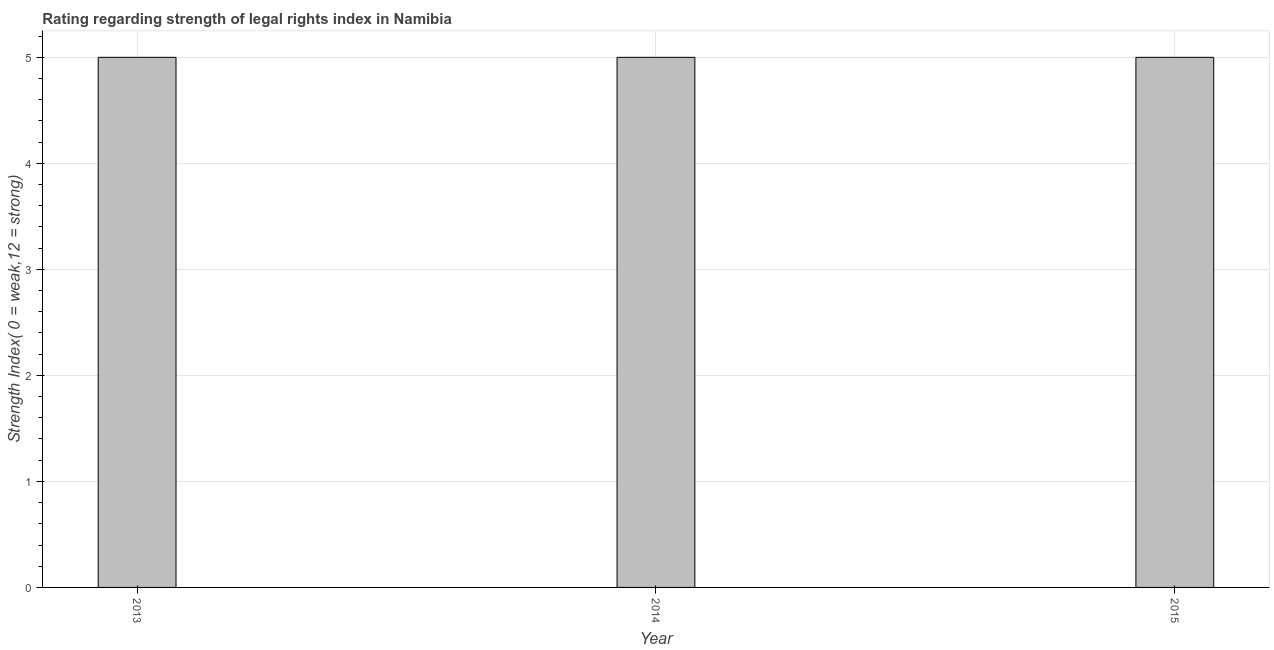Does the graph contain any zero values?
Provide a short and direct response. No. What is the title of the graph?
Offer a terse response. Rating regarding strength of legal rights index in Namibia. What is the label or title of the Y-axis?
Make the answer very short. Strength Index( 0 = weak,12 = strong). What is the strength of legal rights index in 2013?
Provide a short and direct response. 5. What is the average strength of legal rights index per year?
Make the answer very short. 5. What is the ratio of the strength of legal rights index in 2014 to that in 2015?
Offer a very short reply. 1. Is the strength of legal rights index in 2014 less than that in 2015?
Your answer should be compact. No. Is the difference between the strength of legal rights index in 2014 and 2015 greater than the difference between any two years?
Offer a very short reply. Yes. Is the sum of the strength of legal rights index in 2013 and 2014 greater than the maximum strength of legal rights index across all years?
Keep it short and to the point. Yes. In how many years, is the strength of legal rights index greater than the average strength of legal rights index taken over all years?
Ensure brevity in your answer.  0. How many bars are there?
Your response must be concise. 3. Are all the bars in the graph horizontal?
Provide a short and direct response. No. How many years are there in the graph?
Provide a short and direct response. 3. Are the values on the major ticks of Y-axis written in scientific E-notation?
Your response must be concise. No. What is the Strength Index( 0 = weak,12 = strong) of 2013?
Your answer should be very brief. 5. What is the Strength Index( 0 = weak,12 = strong) in 2014?
Your response must be concise. 5. What is the Strength Index( 0 = weak,12 = strong) of 2015?
Offer a terse response. 5. What is the difference between the Strength Index( 0 = weak,12 = strong) in 2013 and 2014?
Offer a terse response. 0. What is the difference between the Strength Index( 0 = weak,12 = strong) in 2013 and 2015?
Make the answer very short. 0. What is the difference between the Strength Index( 0 = weak,12 = strong) in 2014 and 2015?
Provide a short and direct response. 0. 